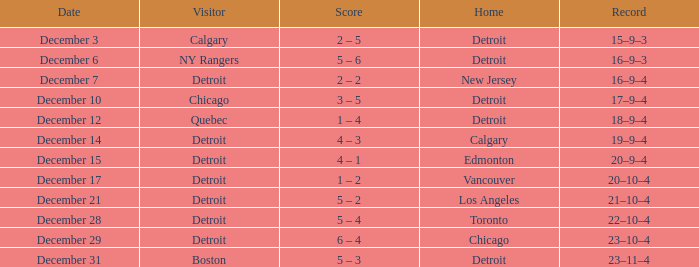What is the planned date for the home team detroit and the guest chicago? December 10. 